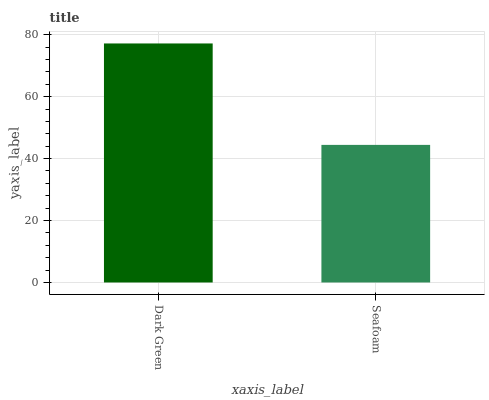Is Seafoam the minimum?
Answer yes or no. Yes. Is Dark Green the maximum?
Answer yes or no. Yes. Is Seafoam the maximum?
Answer yes or no. No. Is Dark Green greater than Seafoam?
Answer yes or no. Yes. Is Seafoam less than Dark Green?
Answer yes or no. Yes. Is Seafoam greater than Dark Green?
Answer yes or no. No. Is Dark Green less than Seafoam?
Answer yes or no. No. Is Dark Green the high median?
Answer yes or no. Yes. Is Seafoam the low median?
Answer yes or no. Yes. Is Seafoam the high median?
Answer yes or no. No. Is Dark Green the low median?
Answer yes or no. No. 